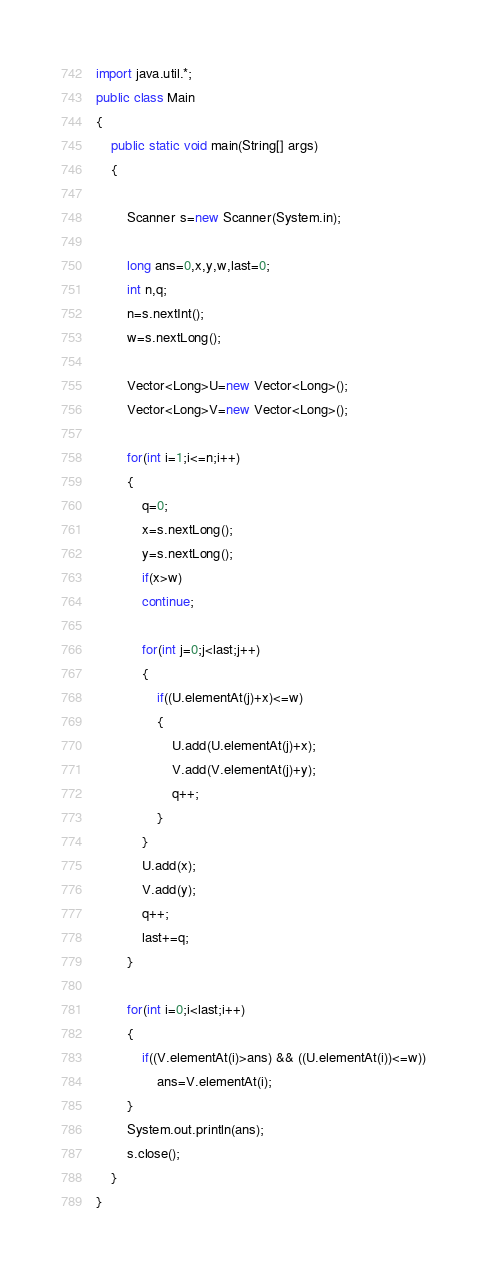Convert code to text. <code><loc_0><loc_0><loc_500><loc_500><_Java_>import java.util.*;
public class Main
{   
    public static void main(String[] args)
    {
    	
        Scanner s=new Scanner(System.in);
        
        long ans=0,x,y,w,last=0;
        int n,q;
        n=s.nextInt();
        w=s.nextLong();
        
        Vector<Long>U=new Vector<Long>();
        Vector<Long>V=new Vector<Long>();
        
        for(int i=1;i<=n;i++)
        {
        	q=0;
        	x=s.nextLong();
        	y=s.nextLong();
            if(x>w)
            continue;
            
            for(int j=0;j<last;j++)
            {
            	if((U.elementAt(j)+x)<=w)
            	{
            		U.add(U.elementAt(j)+x);
            		V.add(V.elementAt(j)+y);
            		q++;
            	}
            }
            U.add(x);
    		V.add(y);
    		q++;
    		last+=q;
        }
        
        for(int i=0;i<last;i++)
        {
        	if((V.elementAt(i)>ans) && ((U.elementAt(i))<=w))
                ans=V.elementAt(i);
        }
        System.out.println(ans);
        s.close();
    }
}</code> 